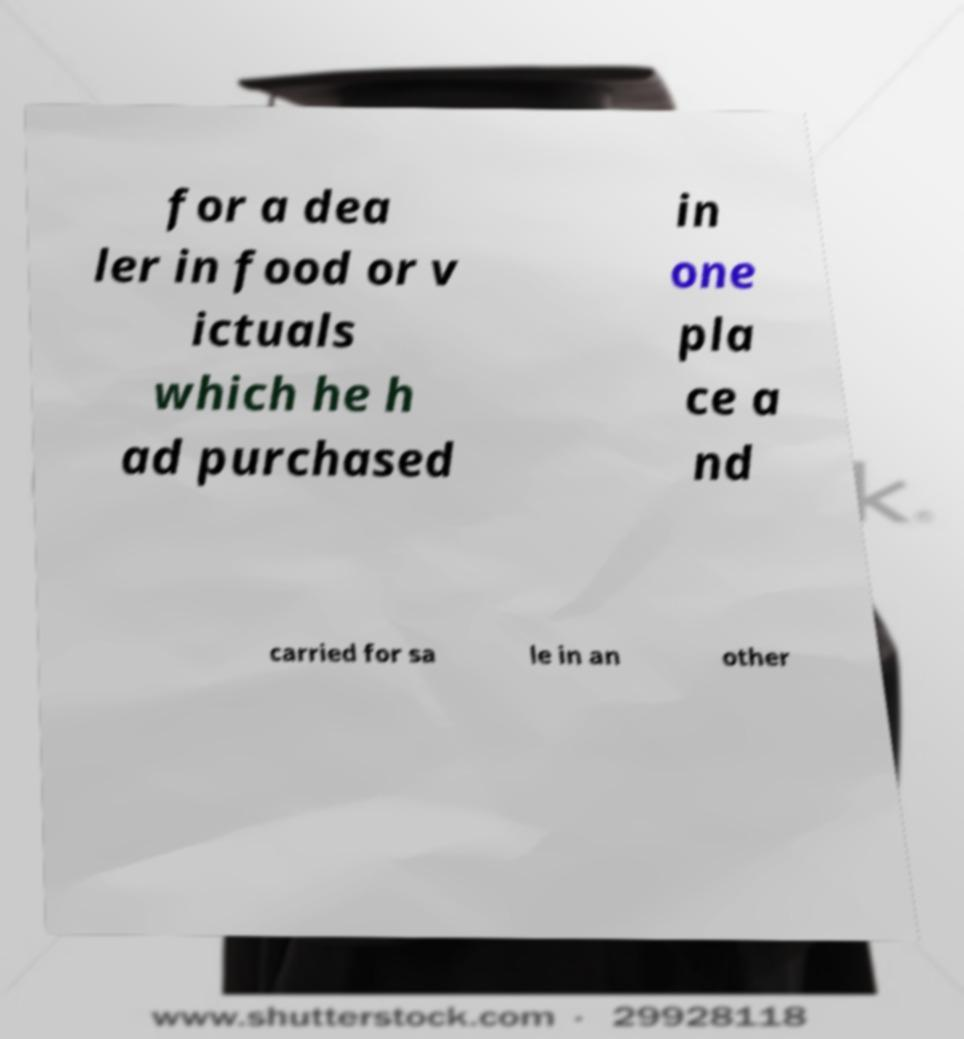Please read and relay the text visible in this image. What does it say? for a dea ler in food or v ictuals which he h ad purchased in one pla ce a nd carried for sa le in an other 